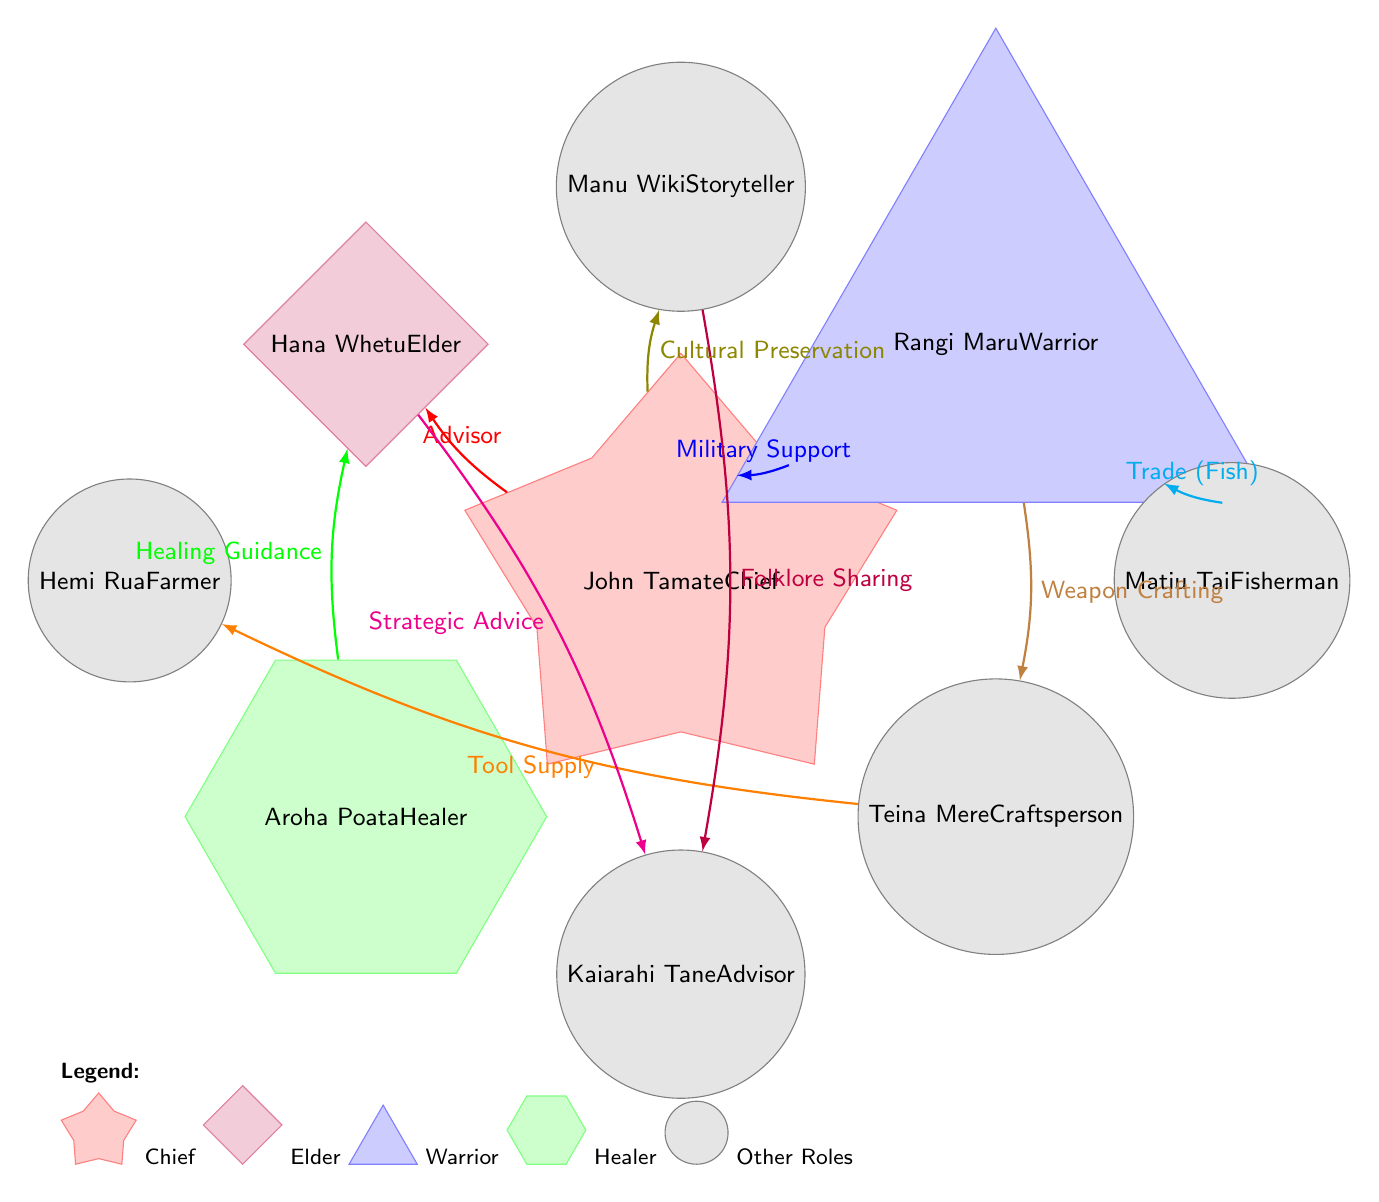What is the role of John Tamate in the village? John Tamate is positioned at the center of the diagram as the Chief, indicated by the star shape and labeled directly with his title.
Answer: Chief How many nodes are present in the diagram? Counting all the distinct shapes representing individuals and their roles, there are 8 nodes in total.
Answer: 8 What is the relationship between the Chief and the Elder? The diagram shows a directed edge from the Chief to the Elder labeled "Advisor," indicating this specific relationship between the two roles.
Answer: Advisor Which individual is a farmer in the village? By locating the node that specifically denotes the role of a Farmer, it is identified as Hemi Rua.
Answer: Hemi Rua Which role provides "Healing Guidance" to the Elder? The diagram indicates that Aroha Poata, who is positioned as the Healer, has a directed relationship with the Elder labeled "Healing Guidance."
Answer: Aroha Poata What type of relationship connects the Warrior and the Craftsperson? Looking at the diagram, the Warrior has a direct relationship with the Craftsperson indicated by the edge labeled "Weapon Crafting."
Answer: Weapon Crafting How many edges are there depicting relationships in the diagram? By counting all the directed connections between nodes in the diagram, there are 9 edges illustrating the various relationships.
Answer: 9 Which role is associated with "Cultural Preservation" in the village? The edge connected to the Storyteller (Manu Wiki) indicates that the Chief has a relationship of "Cultural Preservation" with this role.
Answer: Chief What relationship does the Warrior have with Matiu Tai? The diagram illustrates that the Warrior has a relationship with Matiu Tai, indicated as "Trade (Fish)," connecting them in a cooperative capacity.
Answer: Trade (Fish) 